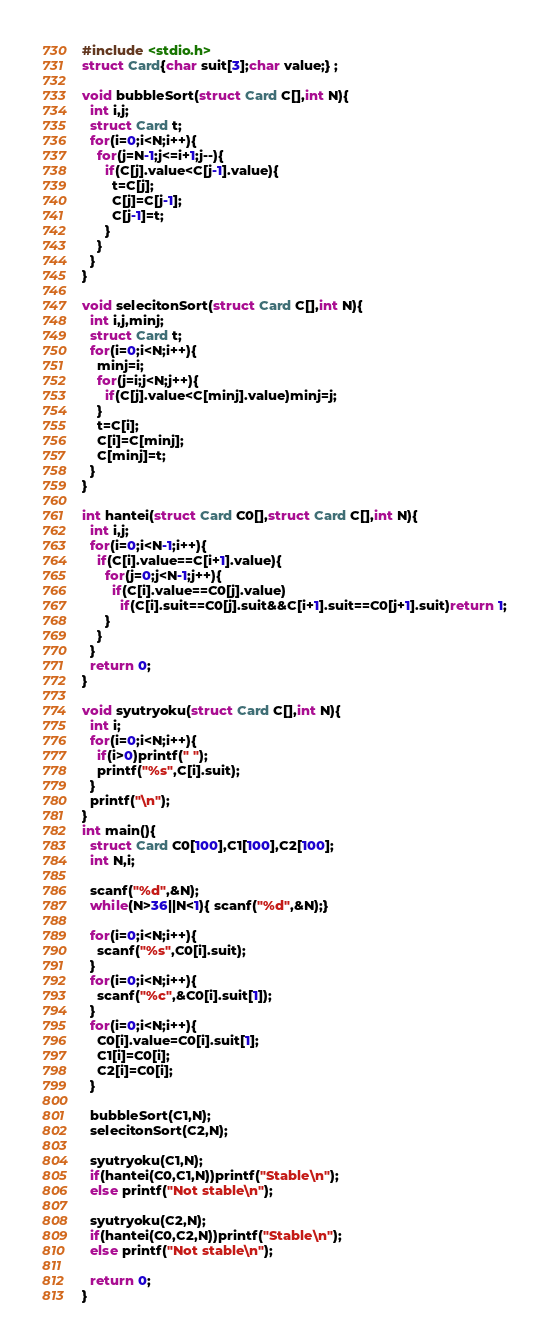Convert code to text. <code><loc_0><loc_0><loc_500><loc_500><_C_>#include <stdio.h>
struct Card{char suit[3];char value;} ;

void bubbleSort(struct Card C[],int N){
  int i,j;
  struct Card t;
  for(i=0;i<N;i++){
    for(j=N-1;j<=i+1;j--){
      if(C[j].value<C[j-1].value){
        t=C[j];
        C[j]=C[j-1];
        C[j-1]=t;
      }
    }
  }
}

void selecitonSort(struct Card C[],int N){
  int i,j,minj;
  struct Card t;
  for(i=0;i<N;i++){
    minj=i;
    for(j=i;j<N;j++){
      if(C[j].value<C[minj].value)minj=j;
    }
    t=C[i];
    C[i]=C[minj];
    C[minj]=t;
  }
}

int hantei(struct Card C0[],struct Card C[],int N){
  int i,j;
  for(i=0;i<N-1;i++){
    if(C[i].value==C[i+1].value){
      for(j=0;j<N-1;j++){
        if(C[i].value==C0[j].value)
          if(C[i].suit==C0[j].suit&&C[i+1].suit==C0[j+1].suit)return 1;
      }
    }  
  }
  return 0;
}

void syutryoku(struct Card C[],int N){
  int i;
  for(i=0;i<N;i++){
    if(i>0)printf(" ");
    printf("%s",C[i].suit);
  }
  printf("\n");
}
int main(){
  struct Card C0[100],C1[100],C2[100];
  int N,i;

  scanf("%d",&N);
  while(N>36||N<1){ scanf("%d",&N);}

  for(i=0;i<N;i++){
    scanf("%s",C0[i].suit);
  }
  for(i=0;i<N;i++){
    scanf("%c",&C0[i].suit[1]);
  }
  for(i=0;i<N;i++){
    C0[i].value=C0[i].suit[1];
    C1[i]=C0[i];
    C2[i]=C0[i];
  }

  bubbleSort(C1,N);
  selecitonSort(C2,N);

  syutryoku(C1,N);
  if(hantei(C0,C1,N))printf("Stable\n");
  else printf("Not stable\n");

  syutryoku(C2,N);
  if(hantei(C0,C2,N))printf("Stable\n");
  else printf("Not stable\n");
  
  return 0;
}

</code> 